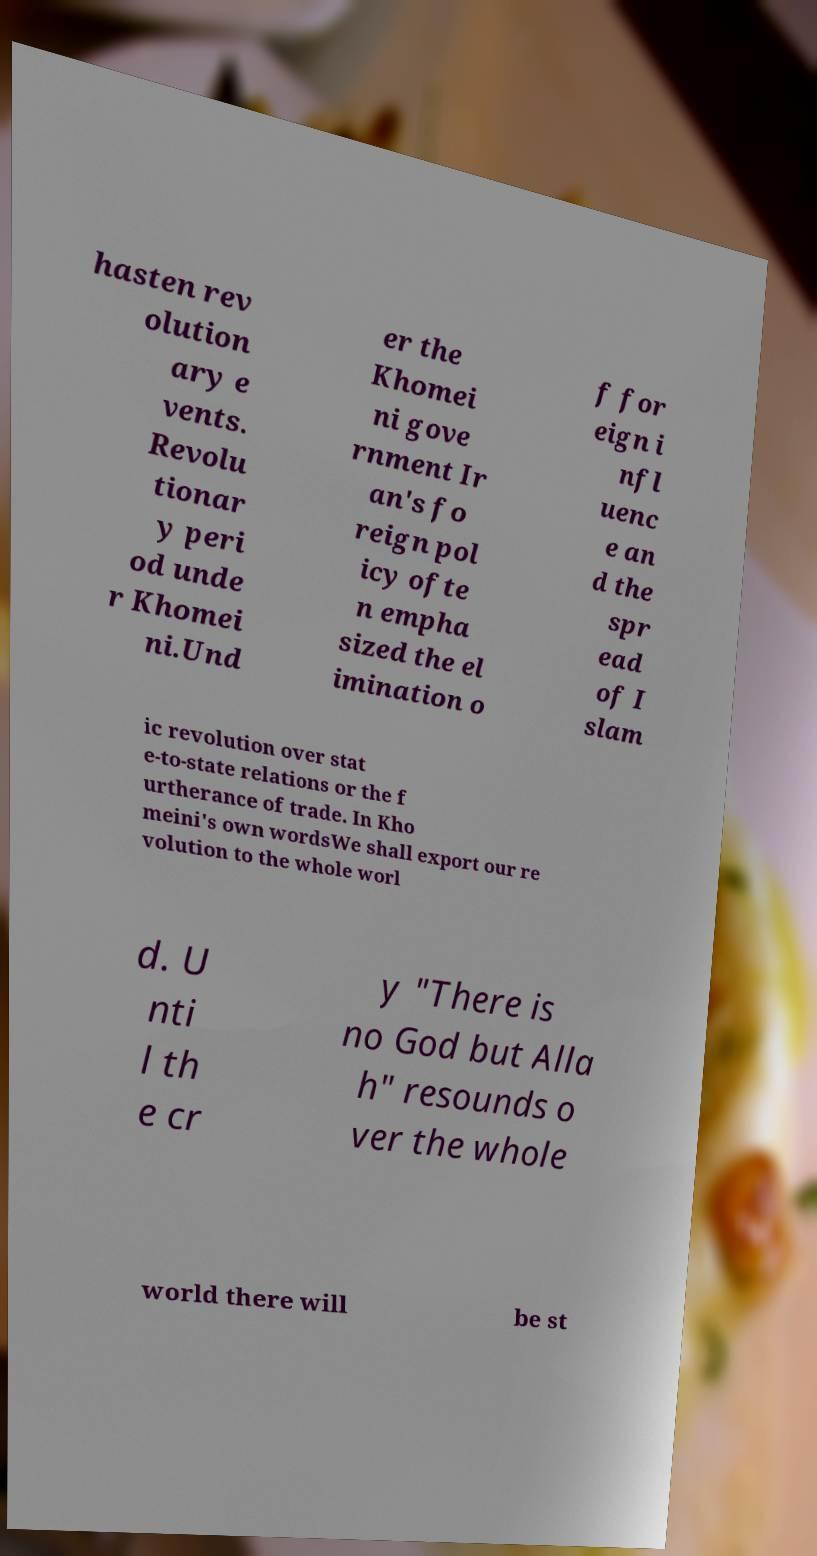Please identify and transcribe the text found in this image. hasten rev olution ary e vents. Revolu tionar y peri od unde r Khomei ni.Und er the Khomei ni gove rnment Ir an's fo reign pol icy ofte n empha sized the el imination o f for eign i nfl uenc e an d the spr ead of I slam ic revolution over stat e-to-state relations or the f urtherance of trade. In Kho meini's own wordsWe shall export our re volution to the whole worl d. U nti l th e cr y "There is no God but Alla h" resounds o ver the whole world there will be st 